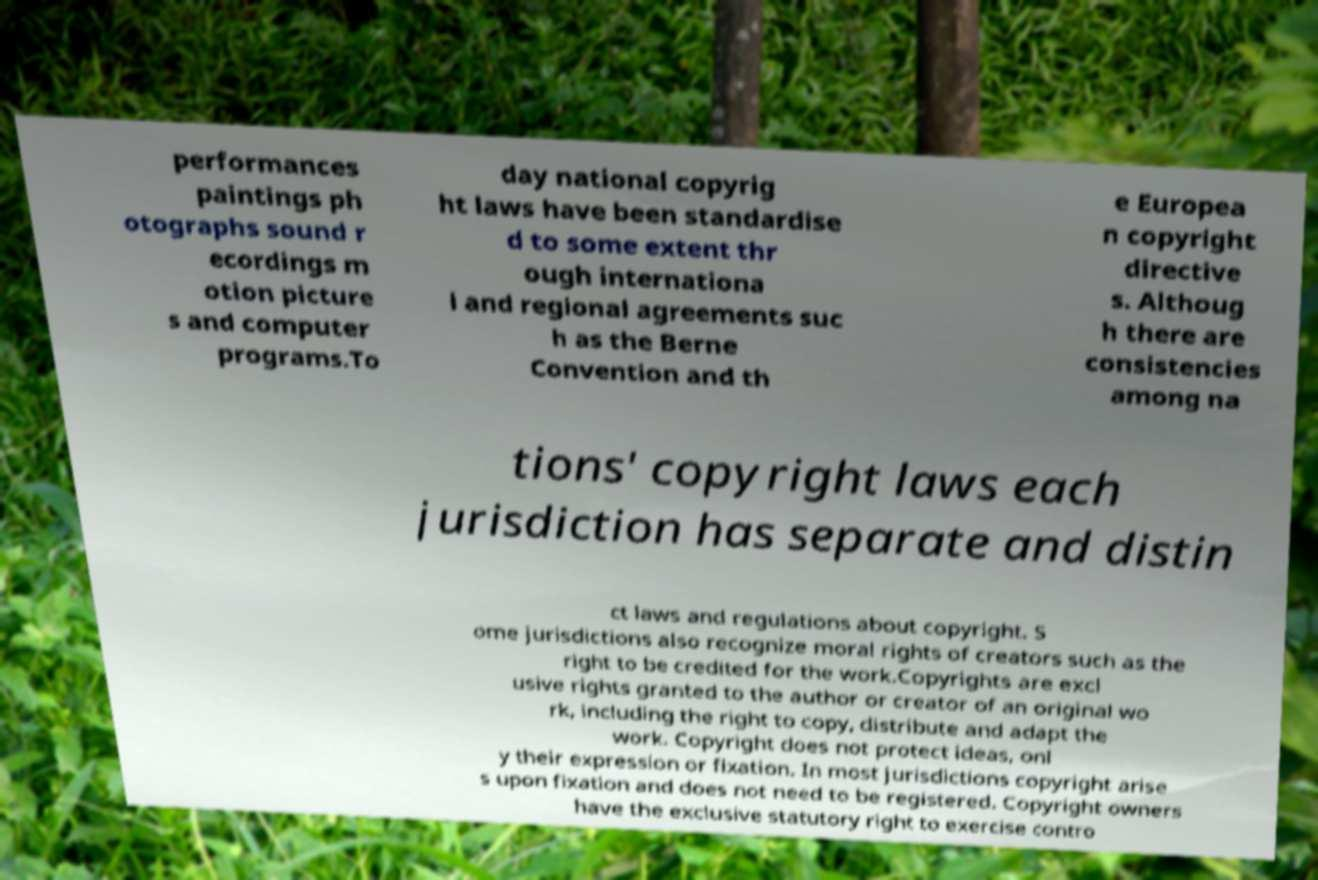Please read and relay the text visible in this image. What does it say? performances paintings ph otographs sound r ecordings m otion picture s and computer programs.To day national copyrig ht laws have been standardise d to some extent thr ough internationa l and regional agreements suc h as the Berne Convention and th e Europea n copyright directive s. Althoug h there are consistencies among na tions' copyright laws each jurisdiction has separate and distin ct laws and regulations about copyright. S ome jurisdictions also recognize moral rights of creators such as the right to be credited for the work.Copyrights are excl usive rights granted to the author or creator of an original wo rk, including the right to copy, distribute and adapt the work. Copyright does not protect ideas, onl y their expression or fixation. In most jurisdictions copyright arise s upon fixation and does not need to be registered. Copyright owners have the exclusive statutory right to exercise contro 